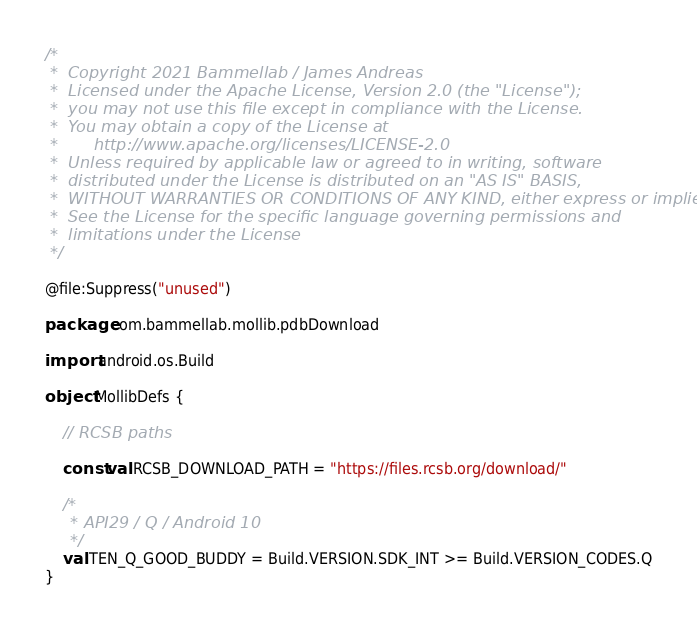<code> <loc_0><loc_0><loc_500><loc_500><_Kotlin_>/*
 *  Copyright 2021 Bammellab / James Andreas
 *  Licensed under the Apache License, Version 2.0 (the "License");
 *  you may not use this file except in compliance with the License.
 *  You may obtain a copy of the License at
 *       http://www.apache.org/licenses/LICENSE-2.0
 *  Unless required by applicable law or agreed to in writing, software
 *  distributed under the License is distributed on an "AS IS" BASIS,
 *  WITHOUT WARRANTIES OR CONDITIONS OF ANY KIND, either express or implied.
 *  See the License for the specific language governing permissions and
 *  limitations under the License
 */

@file:Suppress("unused")

package com.bammellab.mollib.pdbDownload

import android.os.Build

object MollibDefs {

    // RCSB paths

    const val RCSB_DOWNLOAD_PATH = "https://files.rcsb.org/download/"

    /*
     * API29 / Q / Android 10
     */
    val TEN_Q_GOOD_BUDDY = Build.VERSION.SDK_INT >= Build.VERSION_CODES.Q
}
</code> 